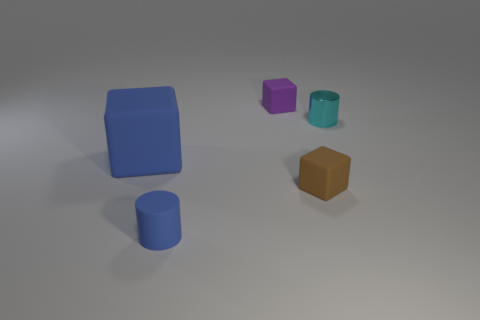Add 2 large red spheres. How many objects exist? 7 Subtract all cylinders. How many objects are left? 3 Subtract 0 gray spheres. How many objects are left? 5 Subtract all cyan rubber cylinders. Subtract all purple rubber blocks. How many objects are left? 4 Add 4 small brown cubes. How many small brown cubes are left? 5 Add 1 cyan metallic cylinders. How many cyan metallic cylinders exist? 2 